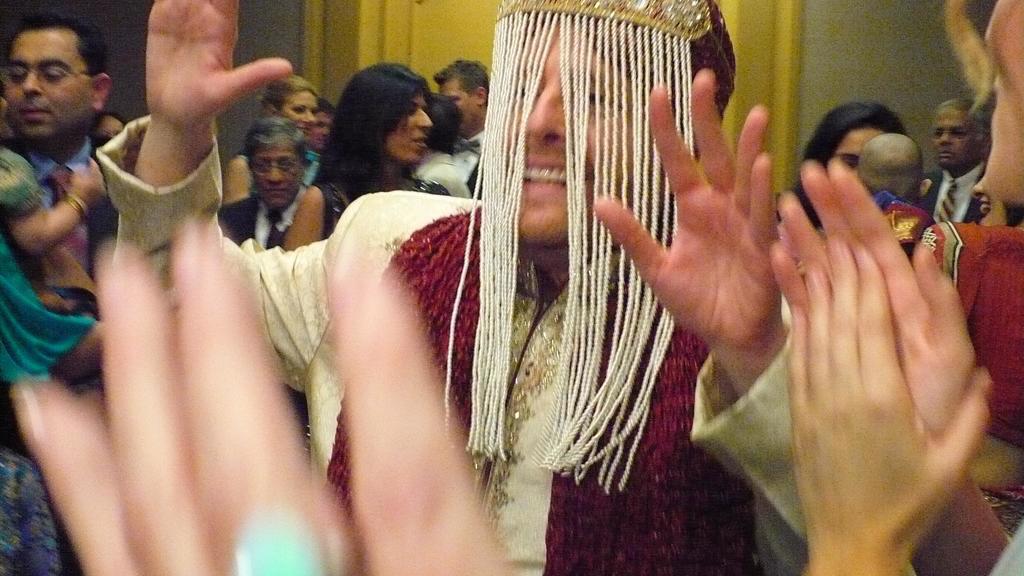Could you give a brief overview of what you see in this image? In this picture we can see a group of people. Behind the people there is a wall and it looks like a door. 